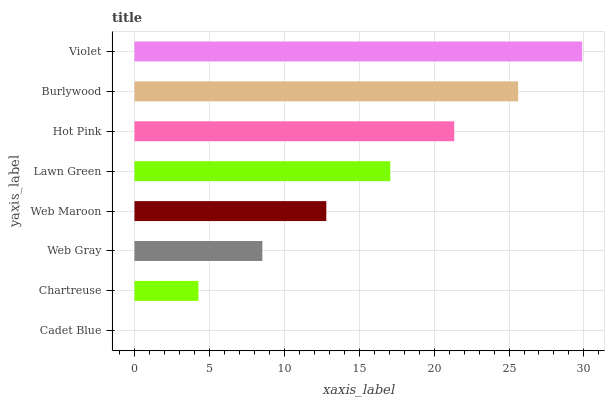Is Cadet Blue the minimum?
Answer yes or no. Yes. Is Violet the maximum?
Answer yes or no. Yes. Is Chartreuse the minimum?
Answer yes or no. No. Is Chartreuse the maximum?
Answer yes or no. No. Is Chartreuse greater than Cadet Blue?
Answer yes or no. Yes. Is Cadet Blue less than Chartreuse?
Answer yes or no. Yes. Is Cadet Blue greater than Chartreuse?
Answer yes or no. No. Is Chartreuse less than Cadet Blue?
Answer yes or no. No. Is Lawn Green the high median?
Answer yes or no. Yes. Is Web Maroon the low median?
Answer yes or no. Yes. Is Web Gray the high median?
Answer yes or no. No. Is Chartreuse the low median?
Answer yes or no. No. 